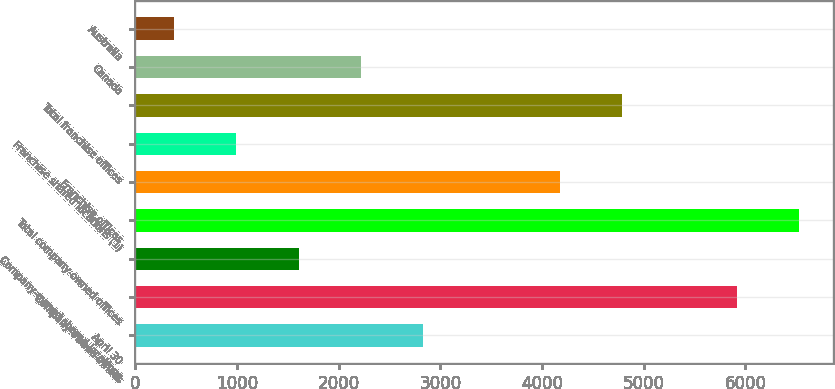Convert chart to OTSL. <chart><loc_0><loc_0><loc_500><loc_500><bar_chart><fcel>April 30<fcel>Company-owned offices<fcel>Company-owned shared locations<fcel>Total company-owned offices<fcel>Franchise offices<fcel>Franchise shared locations (1)<fcel>Total franchise offices<fcel>Canada<fcel>Australia<nl><fcel>2827.6<fcel>5921<fcel>1605.8<fcel>6531.9<fcel>4178<fcel>994.9<fcel>4788.9<fcel>2216.7<fcel>384<nl></chart> 